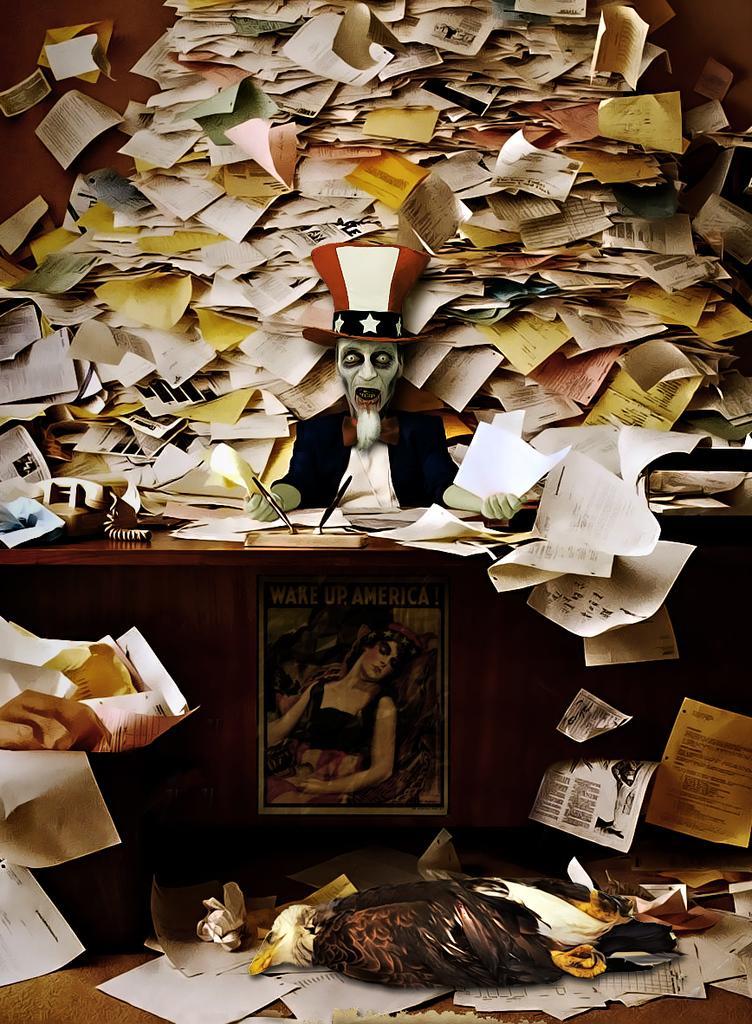In one or two sentences, can you explain what this image depicts? In the foreground of the image we can see a bird is laying down on the papers. In the middle of the image we can see a table on which a telephone and the poster is there and an animated image is there. On the top of the image we can see some papers. Here the complete image is an animation. 